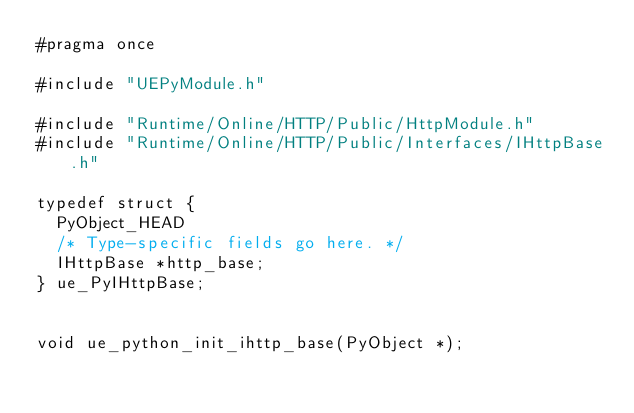Convert code to text. <code><loc_0><loc_0><loc_500><loc_500><_C_>#pragma once

#include "UEPyModule.h"

#include "Runtime/Online/HTTP/Public/HttpModule.h"
#include "Runtime/Online/HTTP/Public/Interfaces/IHttpBase.h"

typedef struct {
	PyObject_HEAD
	/* Type-specific fields go here. */
	IHttpBase *http_base;
} ue_PyIHttpBase;


void ue_python_init_ihttp_base(PyObject *);
</code> 